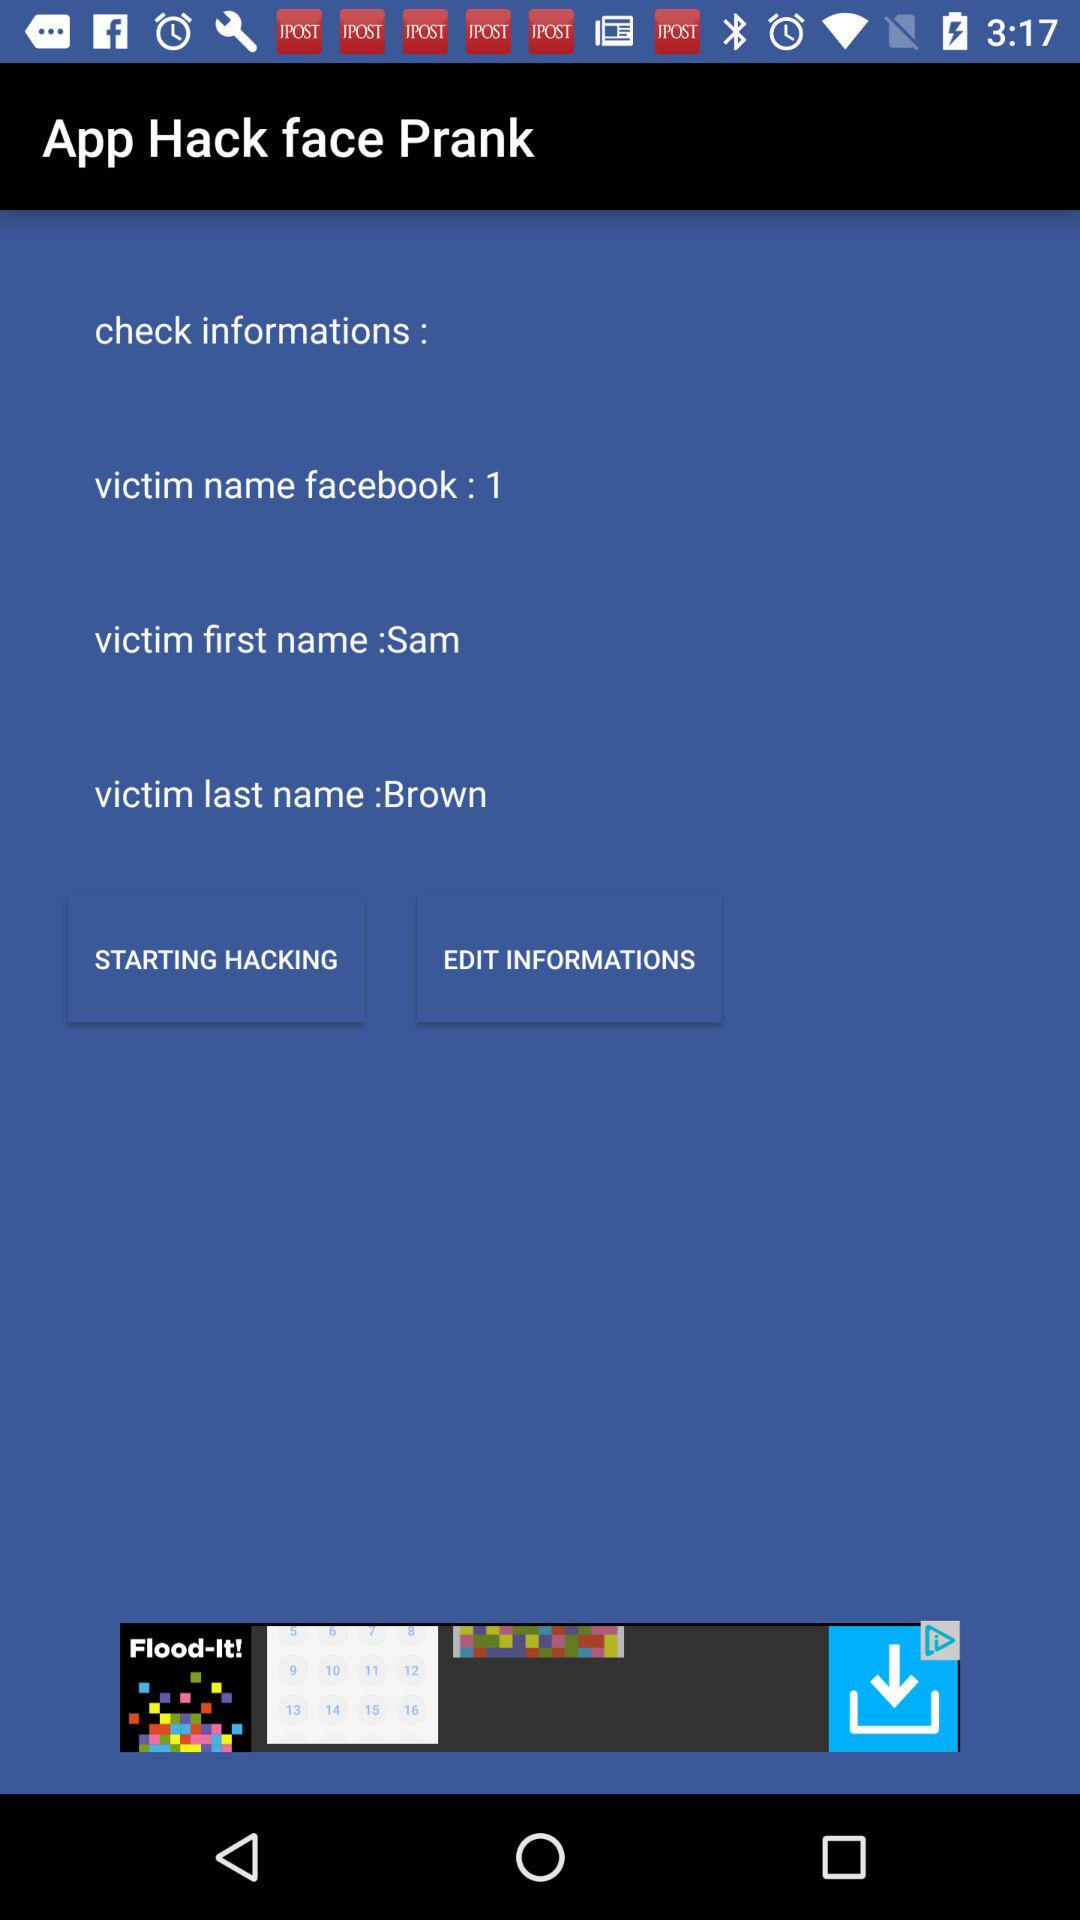What is the name of the application? The name of the application is "App Hack face Prank". 